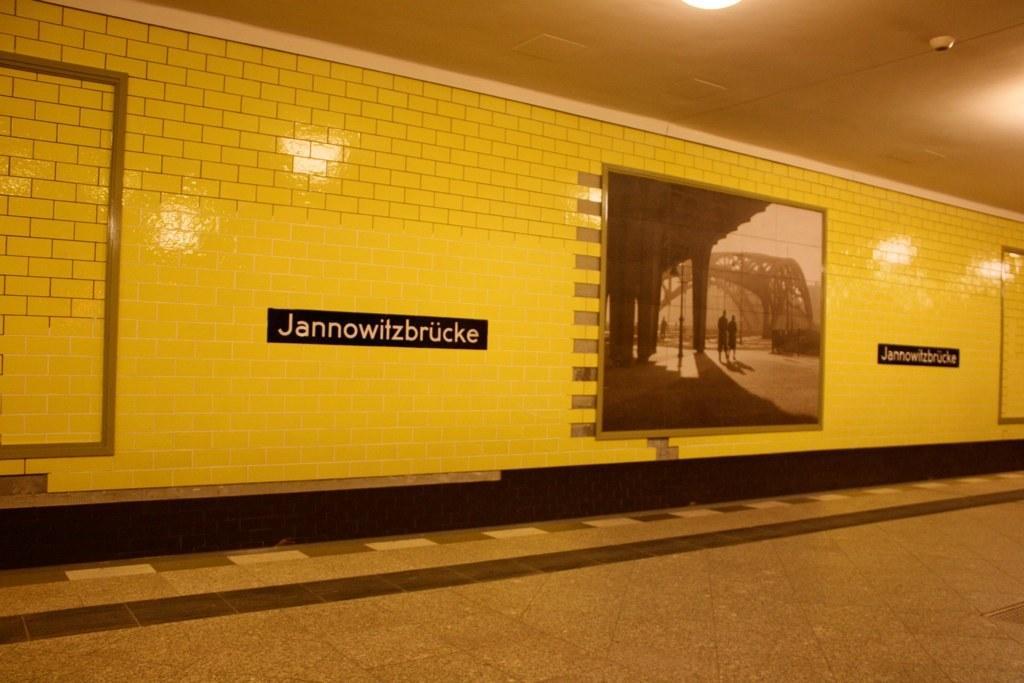Describe this image in one or two sentences. In this image there are frames and name boards attached to the tiles, there is light. 